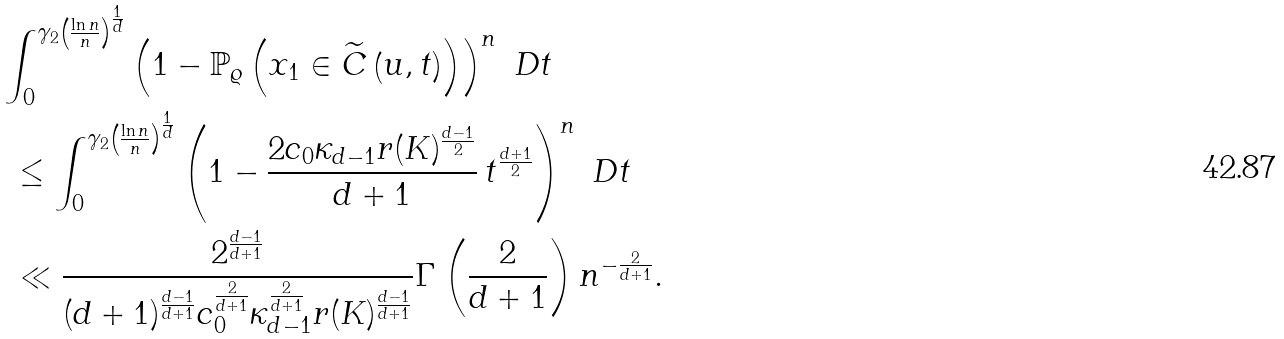<formula> <loc_0><loc_0><loc_500><loc_500>& \int _ { 0 } ^ { \gamma _ { 2 } \left ( \frac { \ln n } { n } \right ) ^ { \frac { 1 } { d } } } \left ( 1 - \mathbb { P } _ { \varrho } \left ( x _ { 1 } \in \widetilde { C } \left ( u , t \right ) \right ) \right ) ^ { n } \ D t \\ & \ \leq \int _ { 0 } ^ { \gamma _ { 2 } \left ( \frac { \ln n } { n } \right ) ^ { \frac { 1 } { d } } } \left ( 1 - \frac { 2 c _ { 0 } \kappa _ { d - 1 } r ( K ) ^ { \frac { d - 1 } { 2 } } } { d + 1 } \, t ^ { \frac { d + 1 } { 2 } } \right ) ^ { n } \ D t \\ & \ \ll \frac { 2 ^ { \frac { d - 1 } { d + 1 } } } { ( d + 1 ) ^ { \frac { d - 1 } { d + 1 } } c _ { 0 } ^ { \frac { 2 } { d + 1 } } \kappa _ { d - 1 } ^ { \frac { 2 } { d + 1 } } r ( K ) ^ { \frac { d - 1 } { d + 1 } } } \Gamma \left ( \frac { 2 } { d + 1 } \right ) n ^ { - \frac { 2 } { d + 1 } } .</formula> 